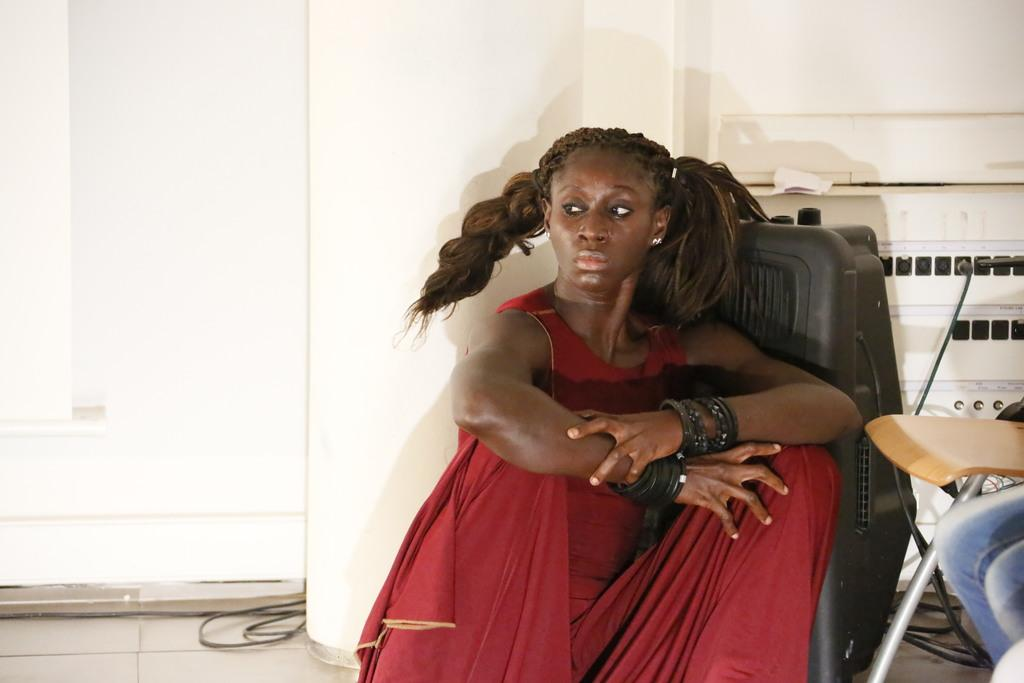Who is the main subject in the image? There is a lady in the image. What is the lady wearing? The lady is wearing a red dress. What is the lady's position in the image? The lady is sitting on the floor. Are there any accessories or markings on the lady's hands? Yes, the lady has black bands on her hand. What other objects can be seen in the image? There is a plug socket and a chair in the image. What type of sticks are being used to create the rainstorm in the image? There is no rainstorm or sticks present in the image. 